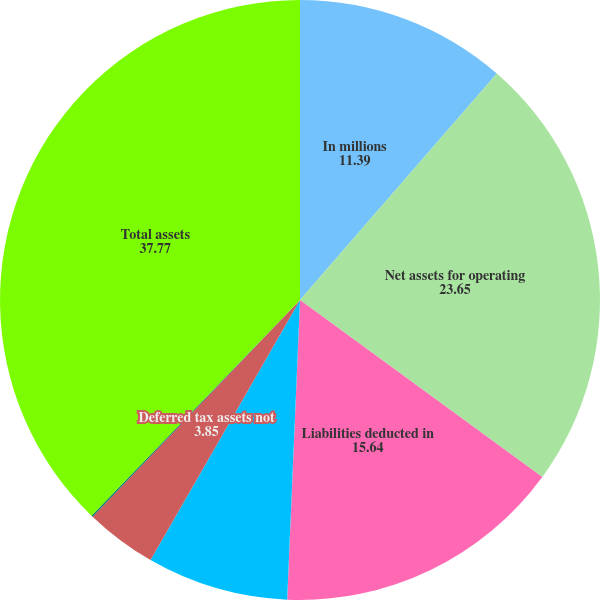Convert chart to OTSL. <chart><loc_0><loc_0><loc_500><loc_500><pie_chart><fcel>In millions<fcel>Net assets for operating<fcel>Liabilities deducted in<fcel>Pension and other<fcel>Deferred tax assets not<fcel>Debt-related costs not<fcel>Total assets<nl><fcel>11.39%<fcel>23.65%<fcel>15.64%<fcel>7.62%<fcel>3.85%<fcel>0.08%<fcel>37.77%<nl></chart> 